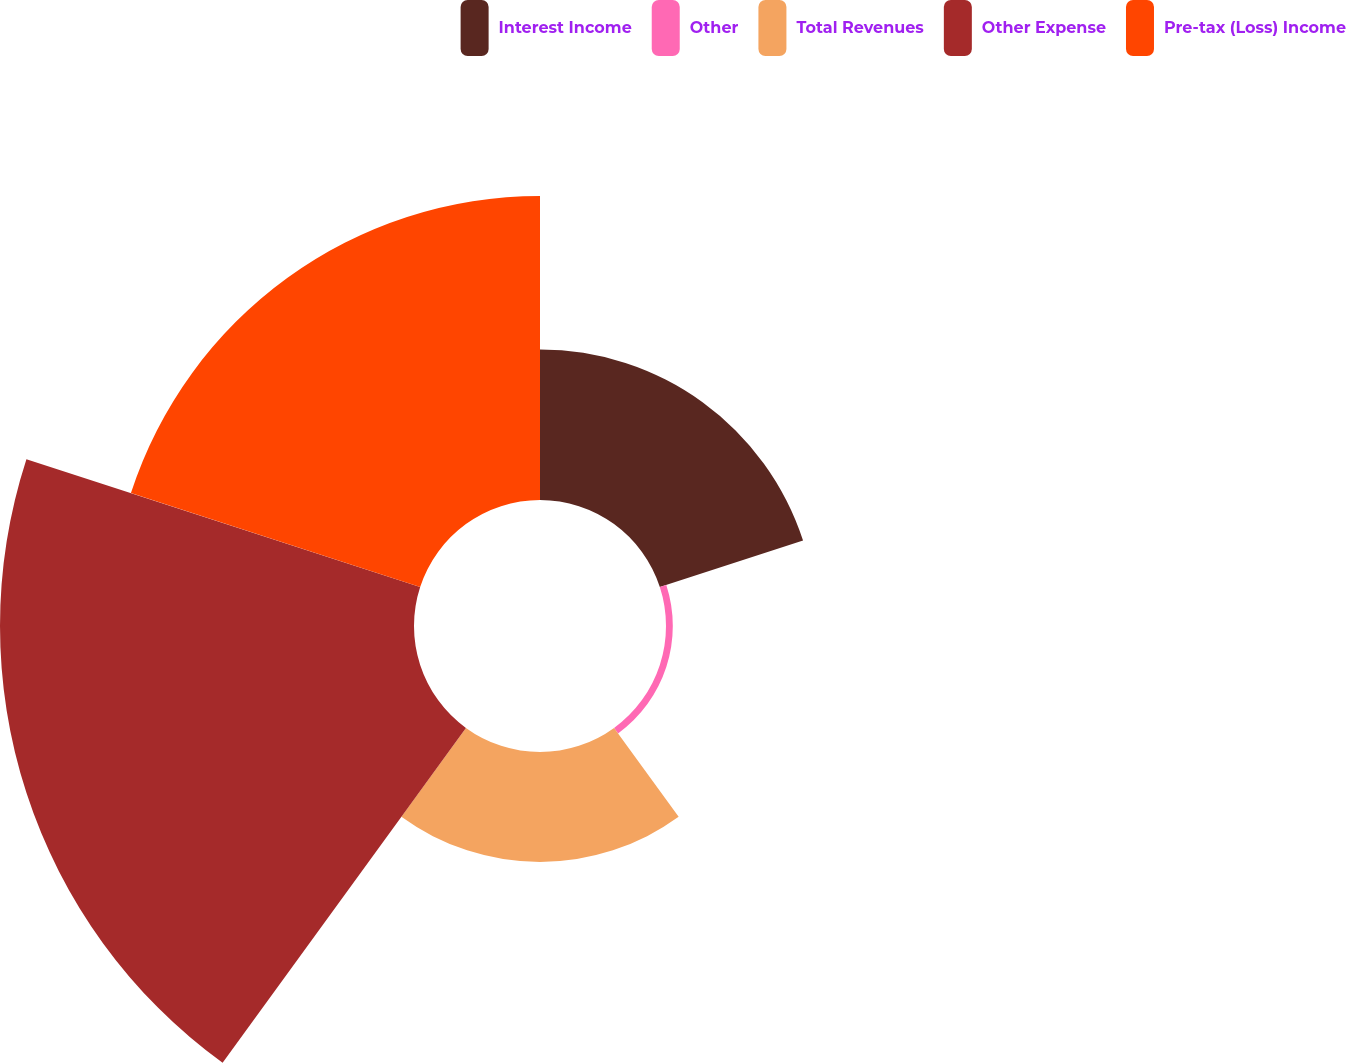<chart> <loc_0><loc_0><loc_500><loc_500><pie_chart><fcel>Interest Income<fcel>Other<fcel>Total Revenues<fcel>Other Expense<fcel>Pre-tax (Loss) Income<nl><fcel>15.28%<fcel>0.69%<fcel>11.15%<fcel>42.01%<fcel>30.86%<nl></chart> 